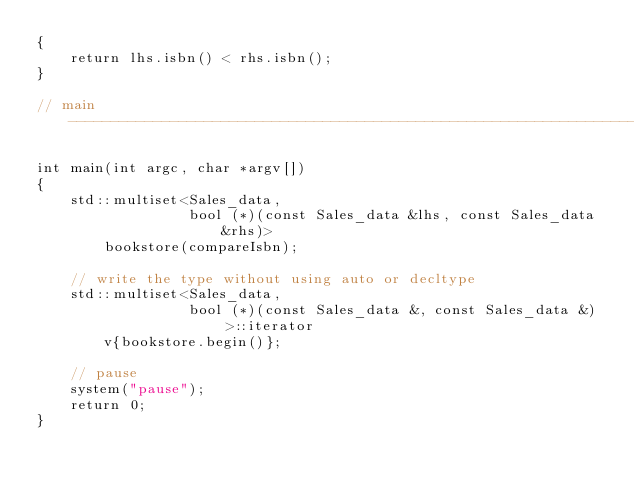<code> <loc_0><loc_0><loc_500><loc_500><_C++_>{
    return lhs.isbn() < rhs.isbn();
}

// main ------------------------------------------------------------------------

int main(int argc, char *argv[])
{
    std::multiset<Sales_data,
                  bool (*)(const Sales_data &lhs, const Sales_data &rhs)>
        bookstore(compareIsbn);

    // write the type without using auto or decltype
    std::multiset<Sales_data,
                  bool (*)(const Sales_data &, const Sales_data &)>::iterator
        v{bookstore.begin()};

    // pause
    system("pause");
    return 0;
}</code> 